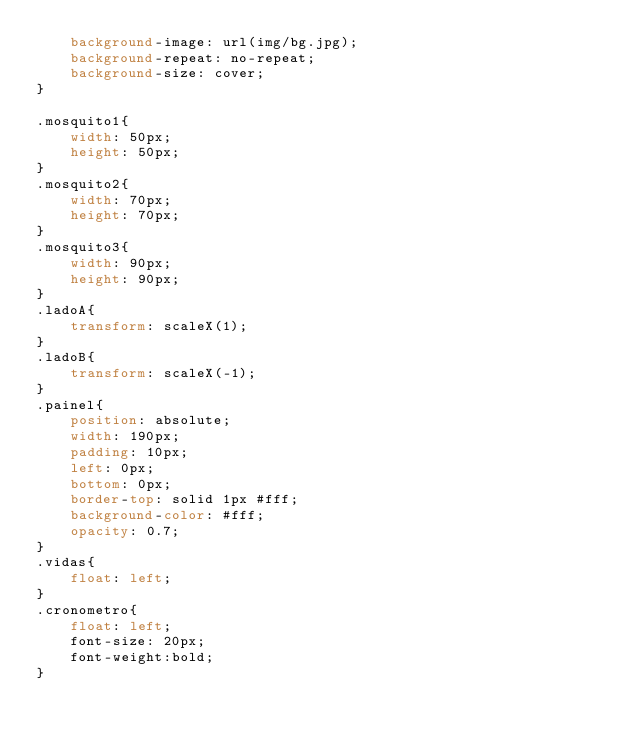<code> <loc_0><loc_0><loc_500><loc_500><_CSS_>    background-image: url(img/bg.jpg);
    background-repeat: no-repeat;
    background-size: cover;
}

.mosquito1{
    width: 50px;
    height: 50px;
}
.mosquito2{
    width: 70px;
    height: 70px;
}
.mosquito3{
    width: 90px;
    height: 90px;
}
.ladoA{
    transform: scaleX(1);
}
.ladoB{
    transform: scaleX(-1);
}
.painel{
    position: absolute;
    width: 190px;
    padding: 10px;
    left: 0px;
    bottom: 0px;
    border-top: solid 1px #fff;
    background-color: #fff;
    opacity: 0.7;
}
.vidas{
    float: left;
}
.cronometro{
    float: left;
    font-size: 20px;
    font-weight:bold;
}

</code> 